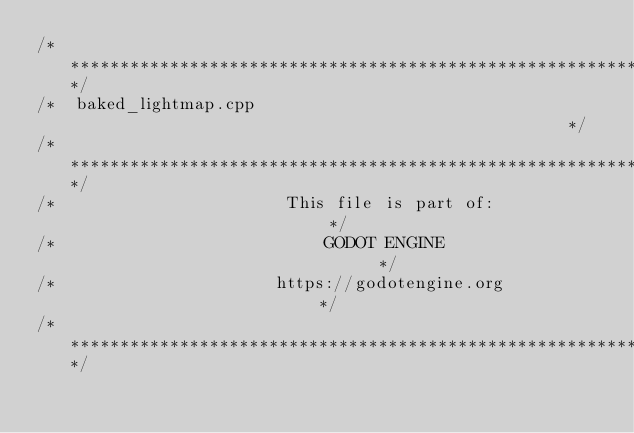Convert code to text. <code><loc_0><loc_0><loc_500><loc_500><_C++_>/*************************************************************************/
/*  baked_lightmap.cpp                                                   */
/*************************************************************************/
/*                       This file is part of:                           */
/*                           GODOT ENGINE                                */
/*                      https://godotengine.org                          */
/*************************************************************************/</code> 